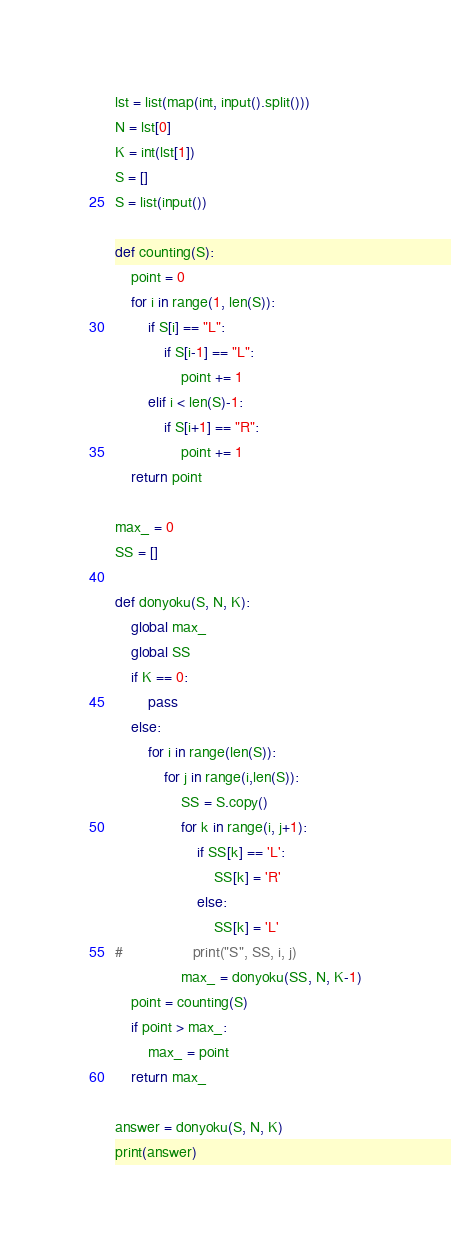Convert code to text. <code><loc_0><loc_0><loc_500><loc_500><_Python_>lst = list(map(int, input().split()))
N = lst[0]
K = int(lst[1])
S = []
S = list(input())

def counting(S):
    point = 0
    for i in range(1, len(S)):
        if S[i] == "L":
            if S[i-1] == "L":
                point += 1
        elif i < len(S)-1:
            if S[i+1] == "R":
                point += 1
    return point

max_ = 0
SS = []

def donyoku(S, N, K):
    global max_
    global SS
    if K == 0:
        pass
    else:
        for i in range(len(S)):
            for j in range(i,len(S)):
                SS = S.copy()
                for k in range(i, j+1):
                    if SS[k] == 'L':
                        SS[k] = 'R'
                    else:
                        SS[k] = 'L'
#                 print("S", SS, i, j)
                max_ = donyoku(SS, N, K-1)
    point = counting(S)
    if point > max_:
        max_ = point
    return max_
    
answer = donyoku(S, N, K)
print(answer)</code> 